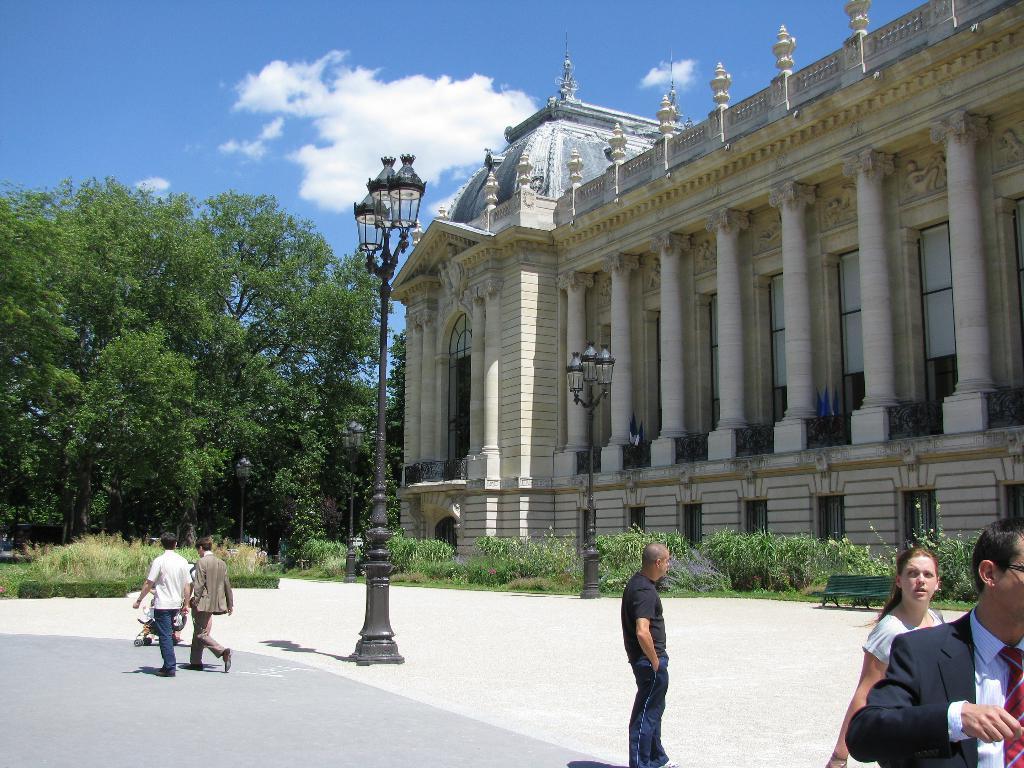Can you describe this image briefly? In this image I see a building over here and I see few light poles and I see the path on which there are few people and I see a bench over here and I can also see number of plants. In the background I see the trees and the clear sky. 